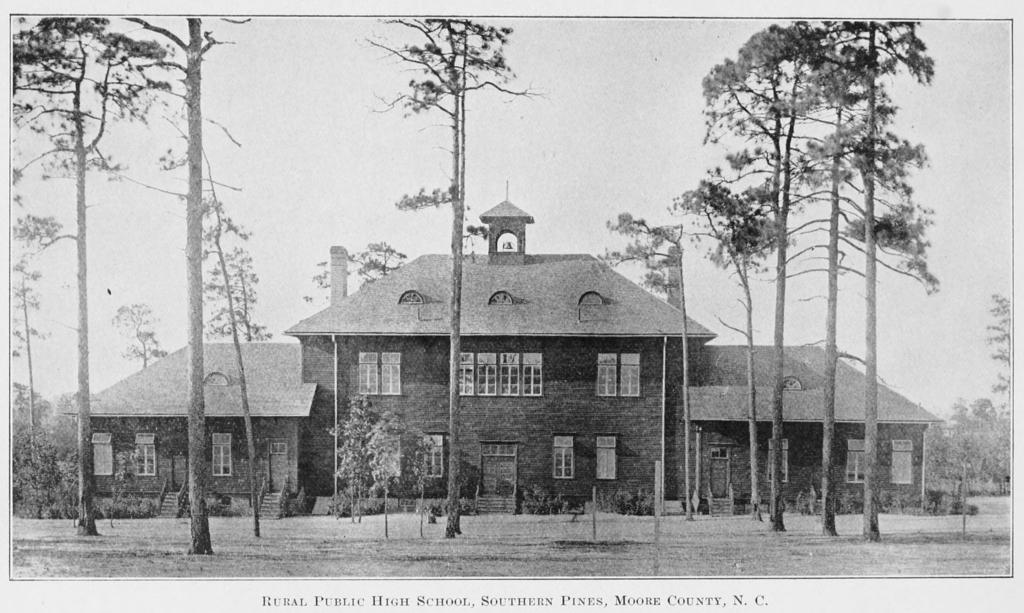What type of structure is visible in the image? There is a house in the image. What feature can be seen on the house? The house has windows. What type of vegetation is present in the image? There are plants and trees in the image. What is visible in the background of the image? The sky is visible in the image. What else can be found in the image besides the house and vegetation? There is text present in the image. How many lizards are crawling on the roof of the house in the image? There are no lizards present in the image, and the roof of the house is not visible. 